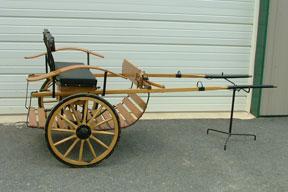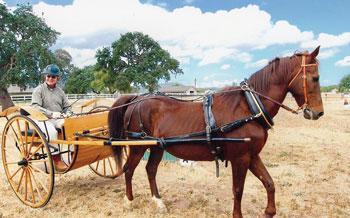The first image is the image on the left, the second image is the image on the right. Analyze the images presented: Is the assertion "One image shows an empty cart parked in front of a garage door." valid? Answer yes or no. Yes. The first image is the image on the left, the second image is the image on the right. For the images shown, is this caption "there is a black horse in the image on the right" true? Answer yes or no. No. 